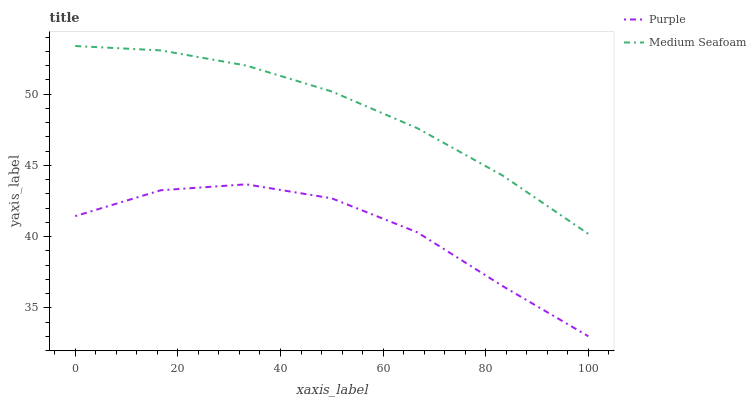Does Purple have the minimum area under the curve?
Answer yes or no. Yes. Does Medium Seafoam have the maximum area under the curve?
Answer yes or no. Yes. Does Medium Seafoam have the minimum area under the curve?
Answer yes or no. No. Is Medium Seafoam the smoothest?
Answer yes or no. Yes. Is Purple the roughest?
Answer yes or no. Yes. Is Medium Seafoam the roughest?
Answer yes or no. No. Does Purple have the lowest value?
Answer yes or no. Yes. Does Medium Seafoam have the lowest value?
Answer yes or no. No. Does Medium Seafoam have the highest value?
Answer yes or no. Yes. Is Purple less than Medium Seafoam?
Answer yes or no. Yes. Is Medium Seafoam greater than Purple?
Answer yes or no. Yes. Does Purple intersect Medium Seafoam?
Answer yes or no. No. 